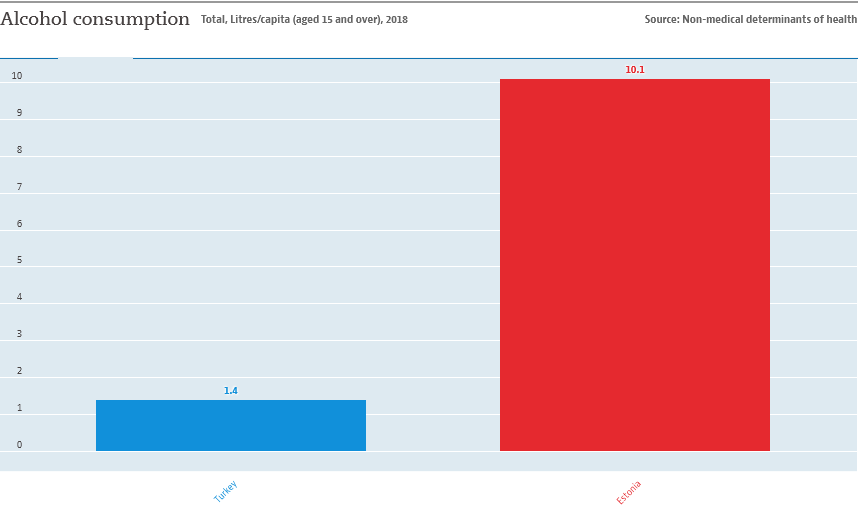Draw attention to some important aspects in this diagram. The average of the two bars is 5.75. The two bars in the chart represent Turkey and Estonia. 